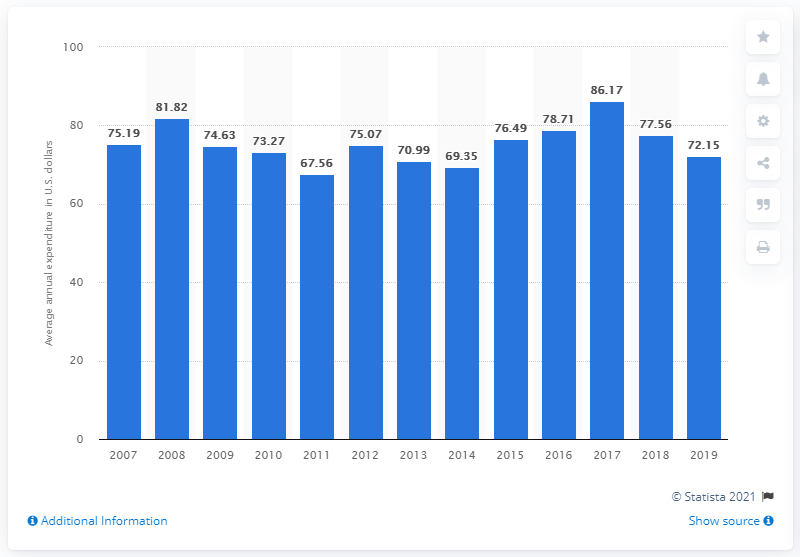Draw attention to some important aspects in this diagram. In the United States in 2019, the average expenditure on stationery, stationery supplies, and giftwrap per consumer unit was $72.15. 